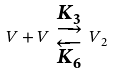<formula> <loc_0><loc_0><loc_500><loc_500>V + V \ _ { \overleftarrow { K _ { 6 } } } ^ { \underrightarrow { K _ { 3 } } } \ V _ { 2 }</formula> 